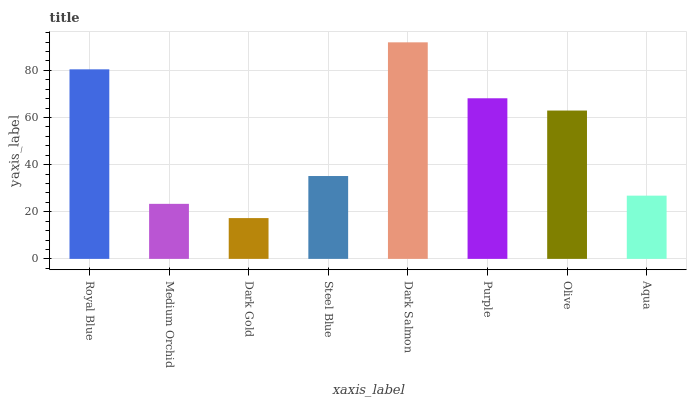Is Dark Gold the minimum?
Answer yes or no. Yes. Is Dark Salmon the maximum?
Answer yes or no. Yes. Is Medium Orchid the minimum?
Answer yes or no. No. Is Medium Orchid the maximum?
Answer yes or no. No. Is Royal Blue greater than Medium Orchid?
Answer yes or no. Yes. Is Medium Orchid less than Royal Blue?
Answer yes or no. Yes. Is Medium Orchid greater than Royal Blue?
Answer yes or no. No. Is Royal Blue less than Medium Orchid?
Answer yes or no. No. Is Olive the high median?
Answer yes or no. Yes. Is Steel Blue the low median?
Answer yes or no. Yes. Is Steel Blue the high median?
Answer yes or no. No. Is Purple the low median?
Answer yes or no. No. 